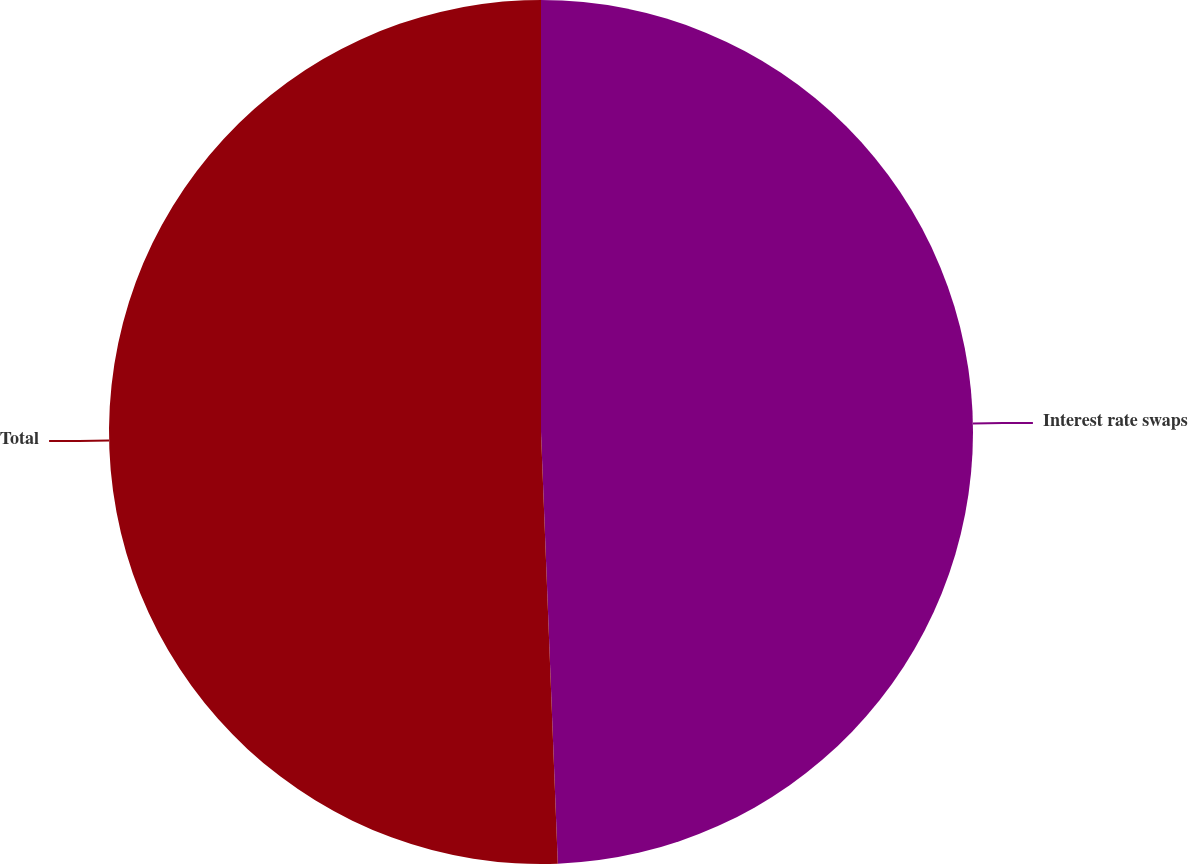<chart> <loc_0><loc_0><loc_500><loc_500><pie_chart><fcel>Interest rate swaps<fcel>Total<nl><fcel>49.38%<fcel>50.62%<nl></chart> 